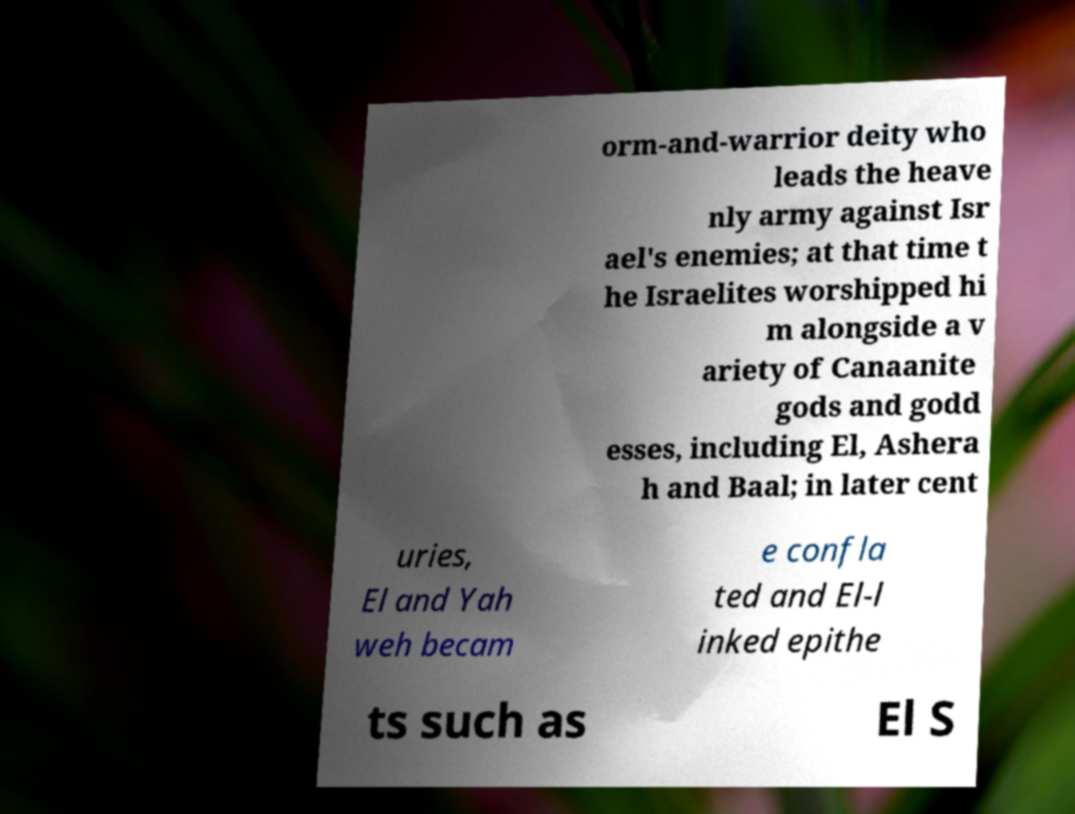Please read and relay the text visible in this image. What does it say? orm-and-warrior deity who leads the heave nly army against Isr ael's enemies; at that time t he Israelites worshipped hi m alongside a v ariety of Canaanite gods and godd esses, including El, Ashera h and Baal; in later cent uries, El and Yah weh becam e confla ted and El-l inked epithe ts such as El S 